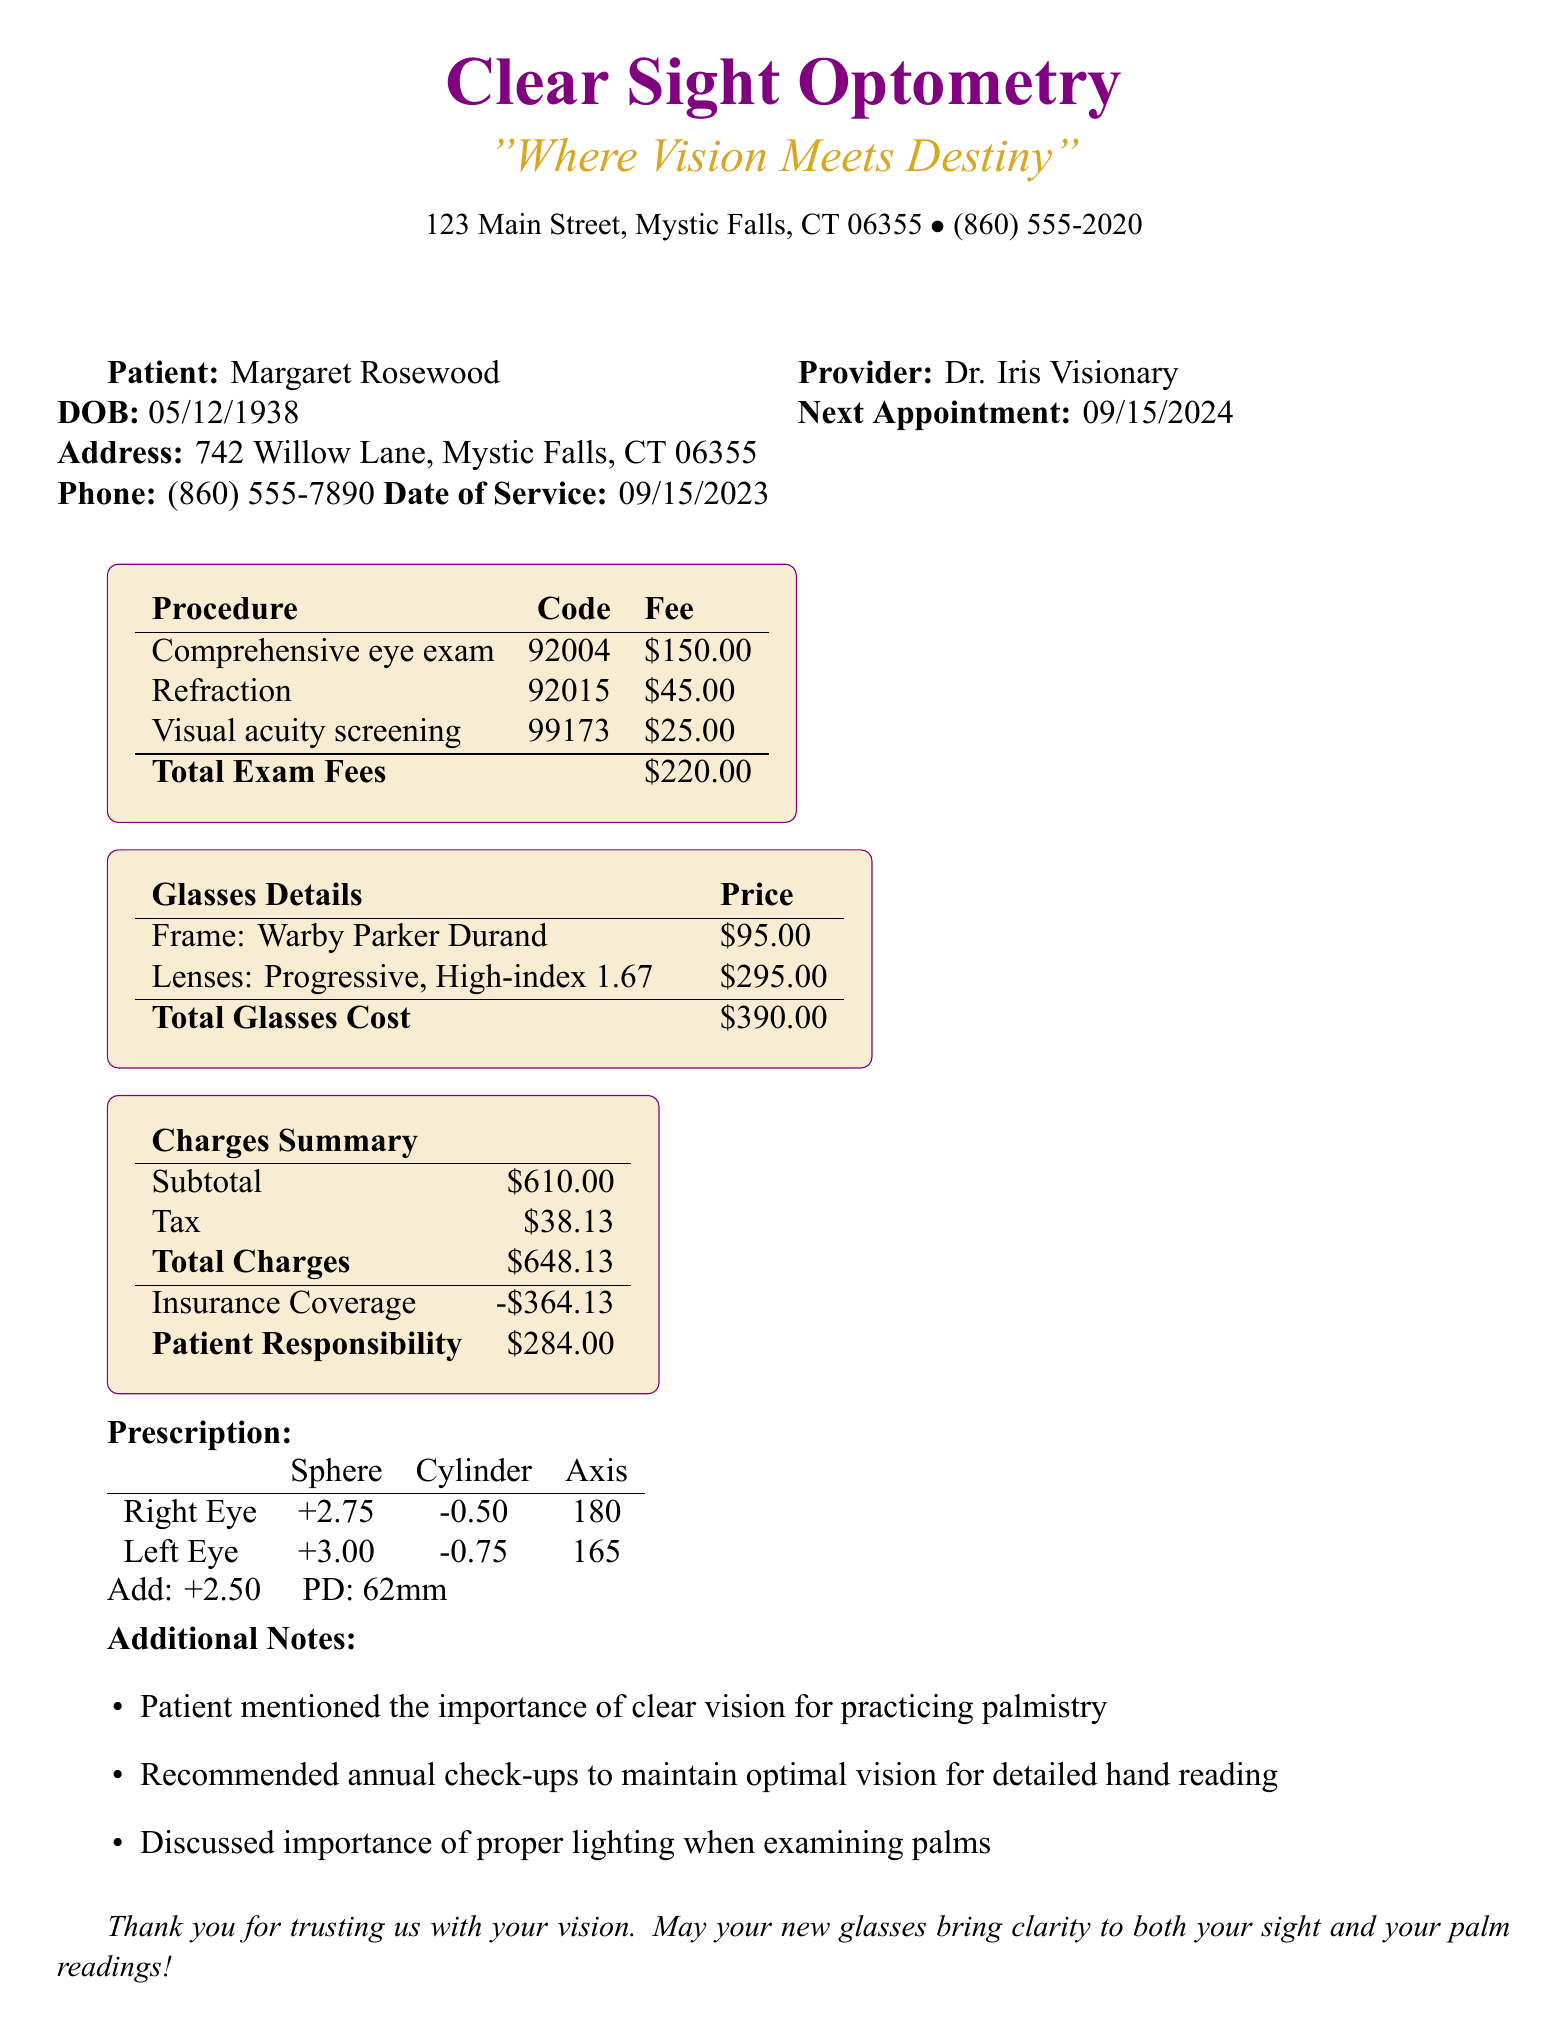What is the patient's name? The patient's name is listed at the beginning of the patient information section.
Answer: Margaret Rosewood What type of exam did the patient receive? The type of exam is provided in the exam details section.
Answer: Comprehensive Eye Exam What is the price of the frame? The price of the frame is found in the glasses details section.
Answer: 95.00 What is the total due from the patient? The total due can be calculated from the patient responsibility section.
Answer: 284.00 Who is the eye care provider? The name of the eye care provider is mentioned in the eye care provider section.
Answer: Dr. Iris Visionary What is the prescription for the right eye's sphere? The sphere value for the right eye is specified in the prescription section.
Answer: +2.75 How much is the insurance allowance for materials? The insurance coverage details the allowance for materials.
Answer: 150 allowance every 24 months What was the reason for the eye exam? The reason for the exam is stated in the exam details section.
Answer: Annual check-up and update prescription for reading glasses What is the next appointment date? The next appointment date is found in the follow-up section.
Answer: 09/15/2024 